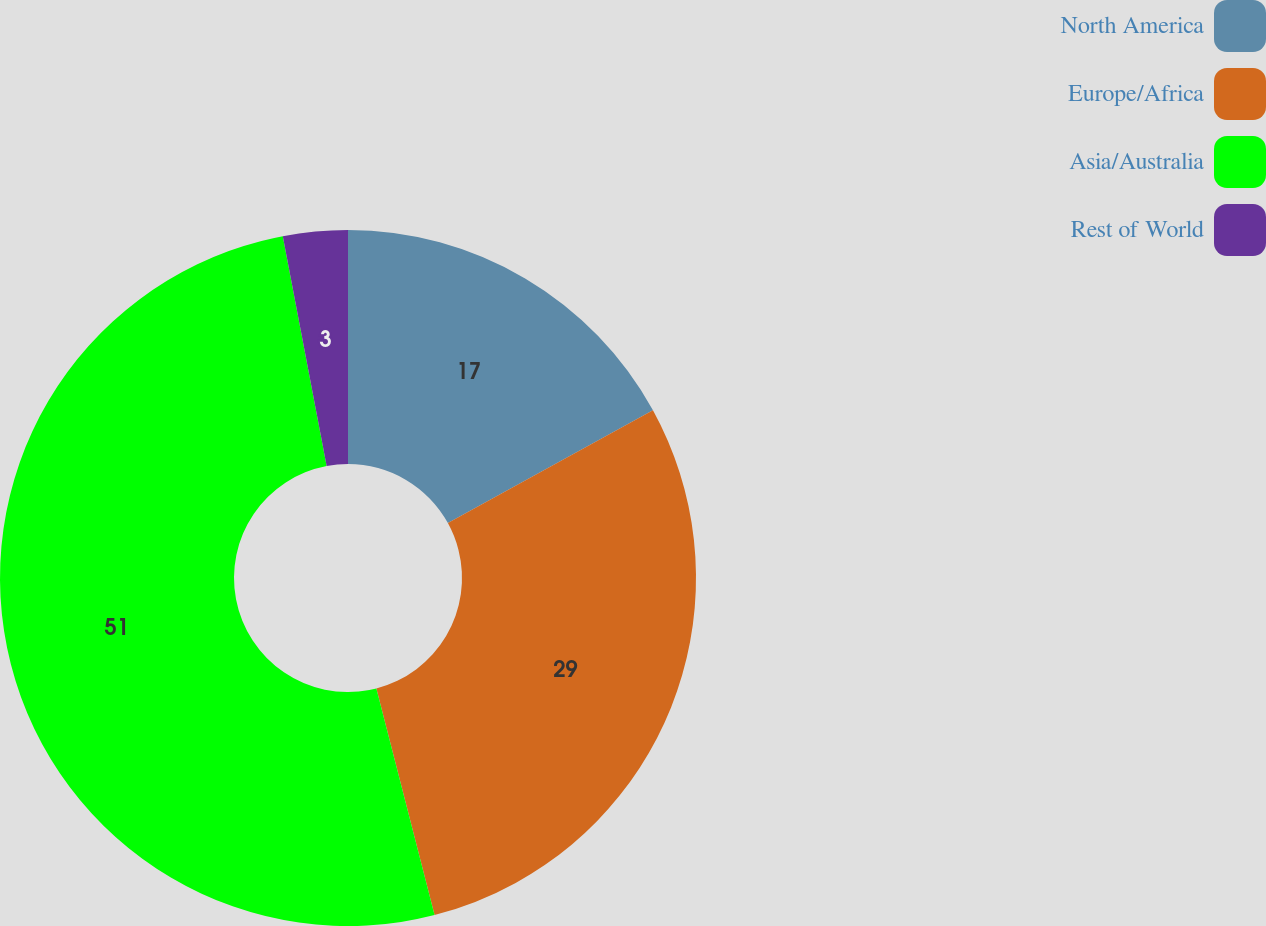<chart> <loc_0><loc_0><loc_500><loc_500><pie_chart><fcel>North America<fcel>Europe/Africa<fcel>Asia/Australia<fcel>Rest of World<nl><fcel>17.0%<fcel>29.0%<fcel>51.0%<fcel>3.0%<nl></chart> 